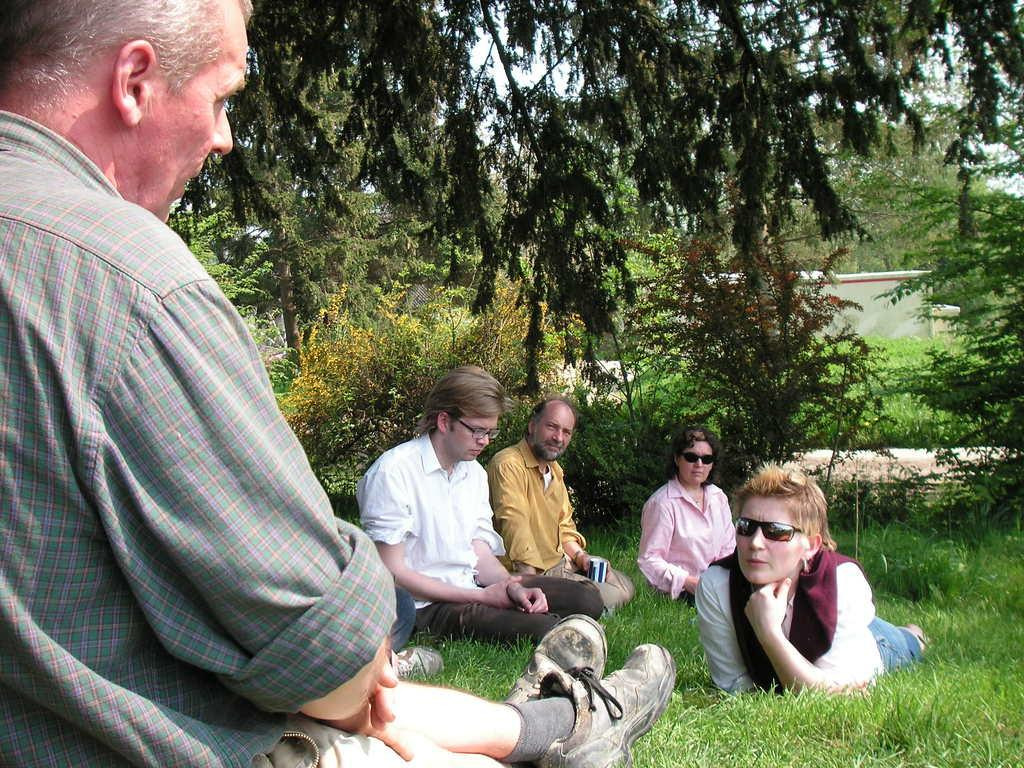What is the main subject of the image? The main subject of the image is a group of people. How are some of the people positioned in the image? Some people are sitting on the grass. What is the woman in the image doing? The woman is lying down. What can be seen in the background of the image? There are trees in the background of the image. What type of reward is being handed out to the people in the image? There is no reward being handed out in the image; it simply shows a group of people, some sitting on the grass and a woman lying down. What advertisement can be seen on the roof in the image? There is no roof or advertisement present in the image. 